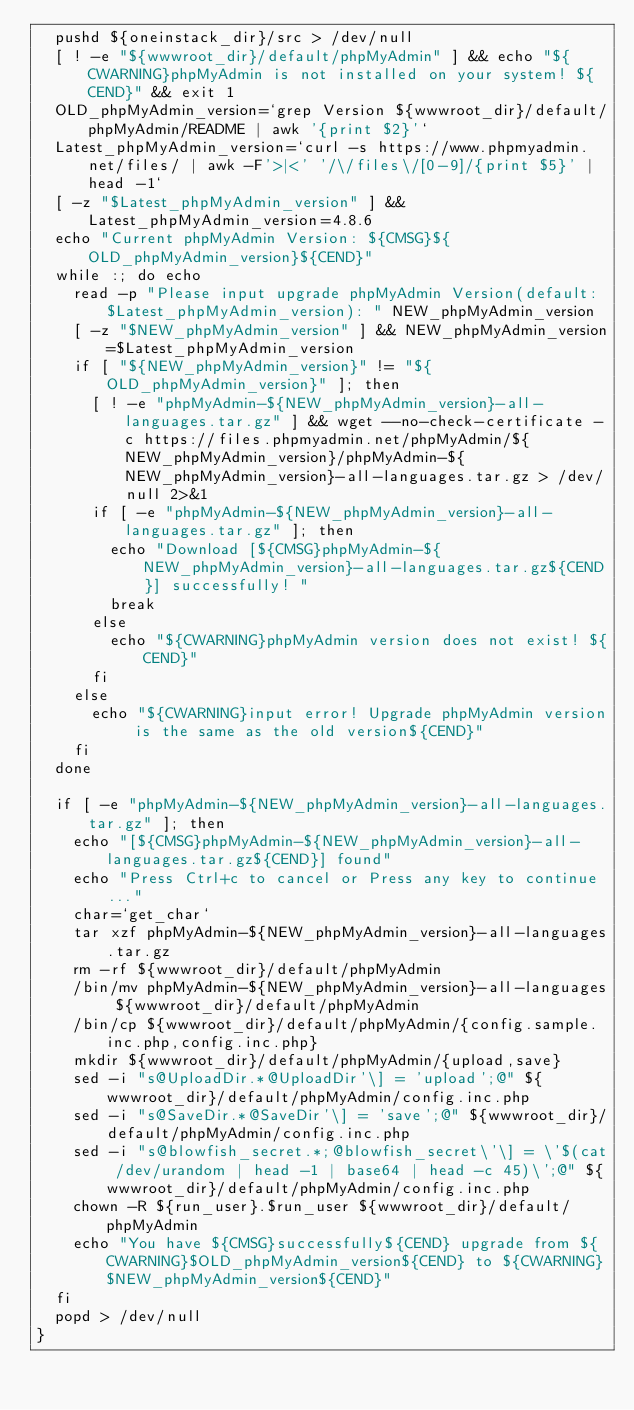<code> <loc_0><loc_0><loc_500><loc_500><_Bash_>  pushd ${oneinstack_dir}/src > /dev/null
  [ ! -e "${wwwroot_dir}/default/phpMyAdmin" ] && echo "${CWARNING}phpMyAdmin is not installed on your system! ${CEND}" && exit 1
  OLD_phpMyAdmin_version=`grep Version ${wwwroot_dir}/default/phpMyAdmin/README | awk '{print $2}'`
  Latest_phpMyAdmin_version=`curl -s https://www.phpmyadmin.net/files/ | awk -F'>|<' '/\/files\/[0-9]/{print $5}' | head -1`
  [ -z "$Latest_phpMyAdmin_version" ] && Latest_phpMyAdmin_version=4.8.6
  echo "Current phpMyAdmin Version: ${CMSG}${OLD_phpMyAdmin_version}${CEND}"
  while :; do echo
    read -p "Please input upgrade phpMyAdmin Version(default: $Latest_phpMyAdmin_version): " NEW_phpMyAdmin_version
    [ -z "$NEW_phpMyAdmin_version" ] && NEW_phpMyAdmin_version=$Latest_phpMyAdmin_version
    if [ "${NEW_phpMyAdmin_version}" != "${OLD_phpMyAdmin_version}" ]; then
      [ ! -e "phpMyAdmin-${NEW_phpMyAdmin_version}-all-languages.tar.gz" ] && wget --no-check-certificate -c https://files.phpmyadmin.net/phpMyAdmin/${NEW_phpMyAdmin_version}/phpMyAdmin-${NEW_phpMyAdmin_version}-all-languages.tar.gz > /dev/null 2>&1
      if [ -e "phpMyAdmin-${NEW_phpMyAdmin_version}-all-languages.tar.gz" ]; then
        echo "Download [${CMSG}phpMyAdmin-${NEW_phpMyAdmin_version}-all-languages.tar.gz${CEND}] successfully! "
        break
      else
        echo "${CWARNING}phpMyAdmin version does not exist! ${CEND}"
      fi
    else
      echo "${CWARNING}input error! Upgrade phpMyAdmin version is the same as the old version${CEND}"
    fi
  done

  if [ -e "phpMyAdmin-${NEW_phpMyAdmin_version}-all-languages.tar.gz" ]; then
    echo "[${CMSG}phpMyAdmin-${NEW_phpMyAdmin_version}-all-languages.tar.gz${CEND}] found"
    echo "Press Ctrl+c to cancel or Press any key to continue..."
    char=`get_char`
    tar xzf phpMyAdmin-${NEW_phpMyAdmin_version}-all-languages.tar.gz
    rm -rf ${wwwroot_dir}/default/phpMyAdmin
    /bin/mv phpMyAdmin-${NEW_phpMyAdmin_version}-all-languages ${wwwroot_dir}/default/phpMyAdmin
    /bin/cp ${wwwroot_dir}/default/phpMyAdmin/{config.sample.inc.php,config.inc.php}
    mkdir ${wwwroot_dir}/default/phpMyAdmin/{upload,save}
    sed -i "s@UploadDir.*@UploadDir'\] = 'upload';@" ${wwwroot_dir}/default/phpMyAdmin/config.inc.php
    sed -i "s@SaveDir.*@SaveDir'\] = 'save';@" ${wwwroot_dir}/default/phpMyAdmin/config.inc.php
    sed -i "s@blowfish_secret.*;@blowfish_secret\'\] = \'$(cat /dev/urandom | head -1 | base64 | head -c 45)\';@" ${wwwroot_dir}/default/phpMyAdmin/config.inc.php
    chown -R ${run_user}.$run_user ${wwwroot_dir}/default/phpMyAdmin
    echo "You have ${CMSG}successfully${CEND} upgrade from ${CWARNING}$OLD_phpMyAdmin_version${CEND} to ${CWARNING}$NEW_phpMyAdmin_version${CEND}"
  fi
  popd > /dev/null
}
</code> 